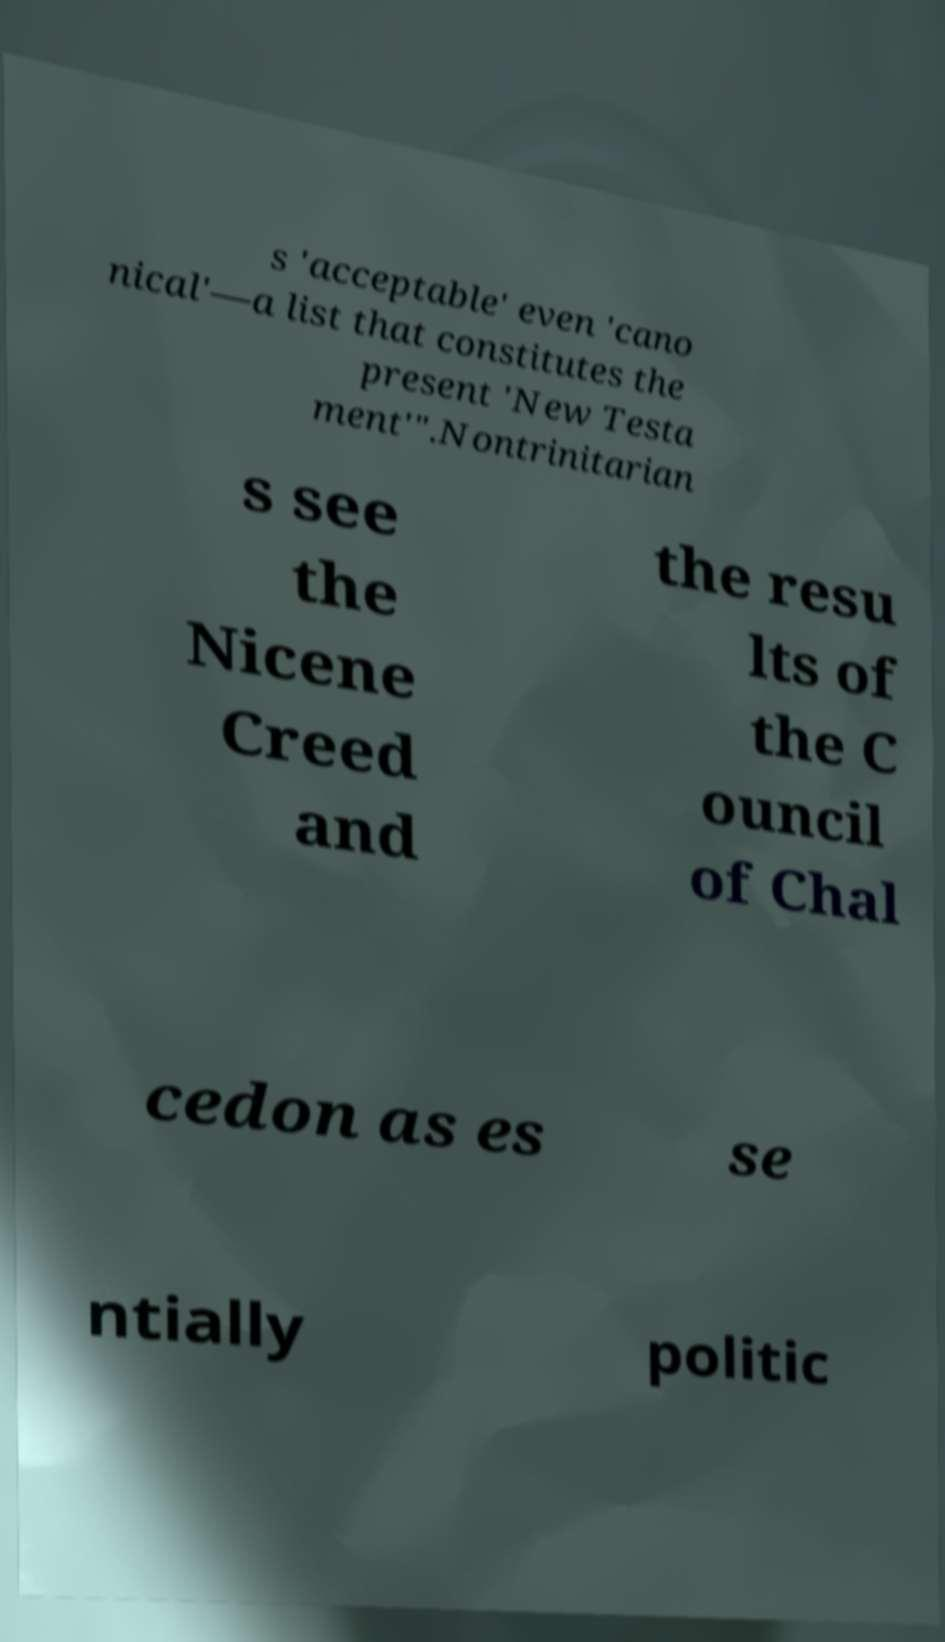Can you accurately transcribe the text from the provided image for me? s 'acceptable' even 'cano nical'—a list that constitutes the present 'New Testa ment'".Nontrinitarian s see the Nicene Creed and the resu lts of the C ouncil of Chal cedon as es se ntially politic 